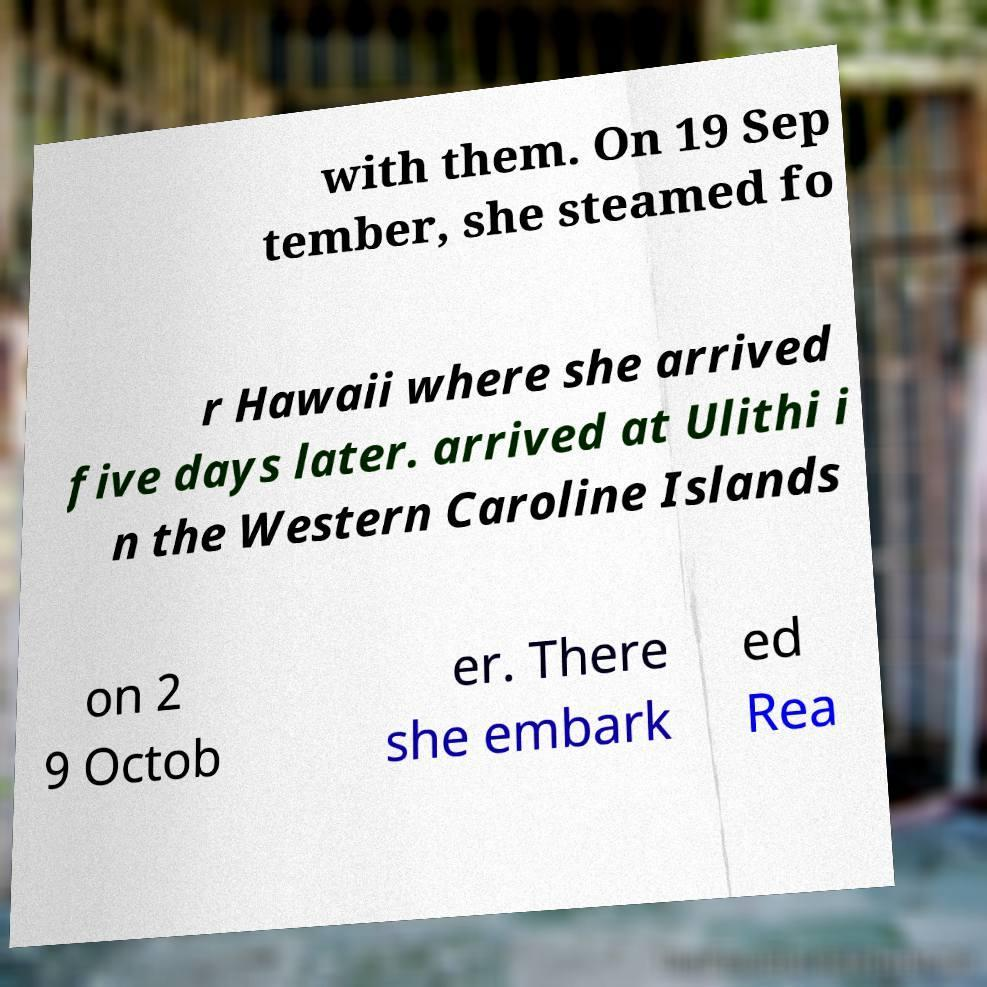What messages or text are displayed in this image? I need them in a readable, typed format. with them. On 19 Sep tember, she steamed fo r Hawaii where she arrived five days later. arrived at Ulithi i n the Western Caroline Islands on 2 9 Octob er. There she embark ed Rea 